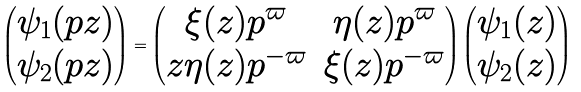Convert formula to latex. <formula><loc_0><loc_0><loc_500><loc_500>\begin{pmatrix} \psi _ { 1 } ( p z ) \\ \psi _ { 2 } ( p z ) \end{pmatrix} = \begin{pmatrix} \xi ( z ) p ^ { \varpi } & \eta ( z ) p ^ { \varpi } \\ z \eta ( z ) p ^ { - \varpi } & \xi ( z ) p ^ { - \varpi } \end{pmatrix} \begin{pmatrix} \psi _ { 1 } ( z ) \\ \psi _ { 2 } ( z ) \end{pmatrix}</formula> 